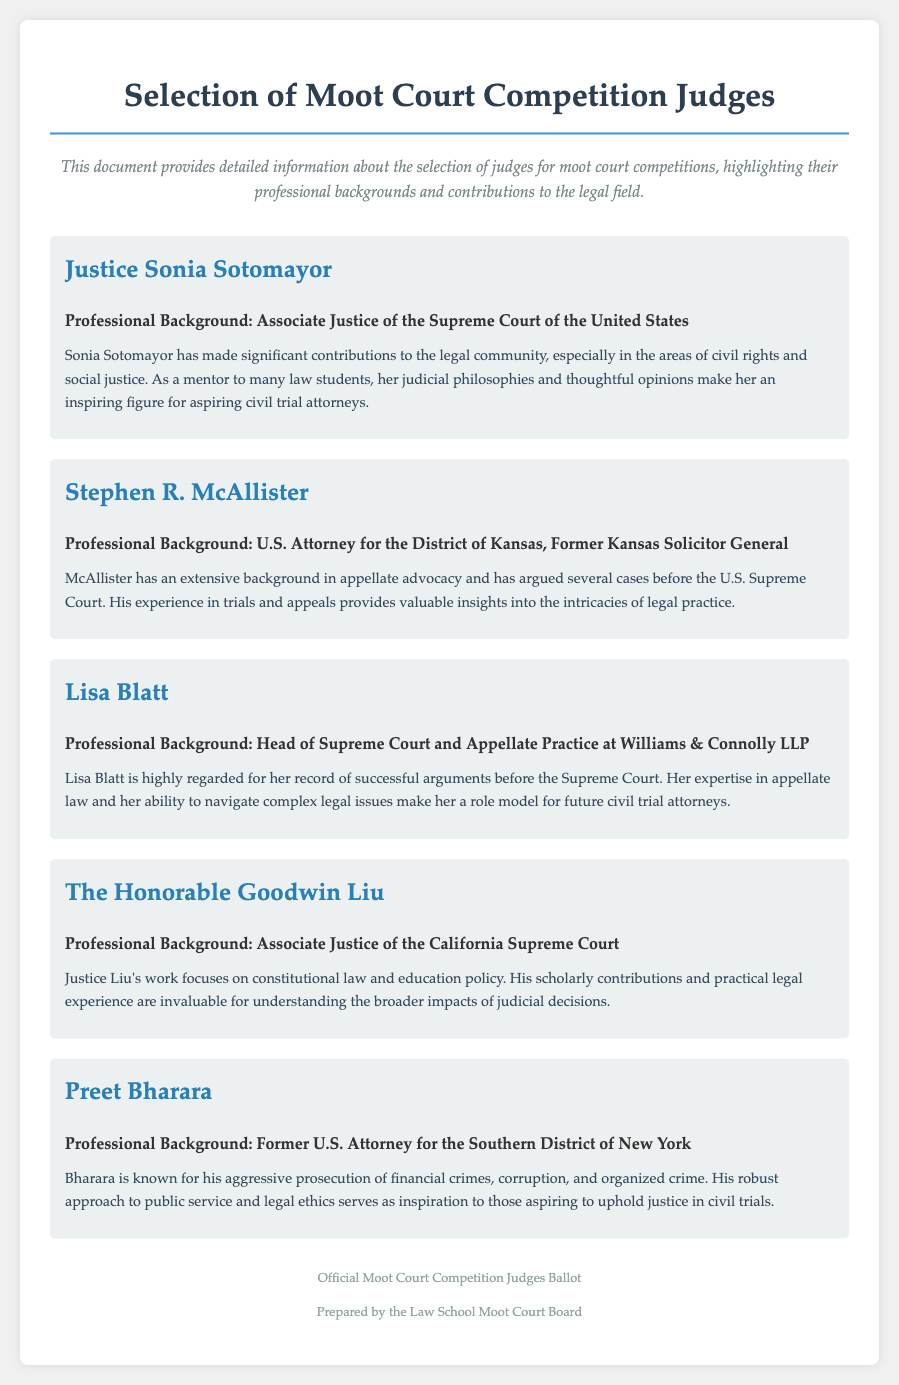What is the title of the document? The title is stated in the header of the document, clearly identifying it as related to judges for a moot court competition.
Answer: Selection of Moot Court Competition Judges Who is the first judge listed? The judges are presented in order, with the first judge being prominently displayed at the top of the list.
Answer: Justice Sonia Sotomayor What role does Lisa Blatt hold? The document specifies the professional backgrounds of the judges, highlighting the role of Lisa Blatt in her respective field.
Answer: Head of Supreme Court and Appellate Practice at Williams & Connolly LLP Which judge focuses on constitutional law? The contributions and professional background sections provide details about each judge's area of expertise and focus.
Answer: The Honorable Goodwin Liu How many judges are featured in the document? The total number of judges can be counted based on the distinct judge sections included in the document.
Answer: Five What notable legal issue is Preet Bharara known for addressing? The contributions section outlines the specific areas in which each judge has made an impact, particularly highlighting Bharara's prosecutorial work.
Answer: Financial crimes What is the purpose of this document? The introduction clearly states the purpose of the document, which is related to the selection process for judges in a moot court competition.
Answer: To provide detailed information about the selection of judges Who prepares the judges ballot? The document credits the Law School Moot Court Board for the preparation of the judges ballot, indicating its source.
Answer: Law School Moot Court Board 